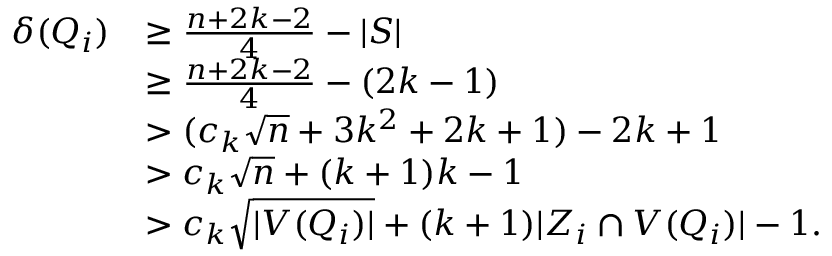<formula> <loc_0><loc_0><loc_500><loc_500>\begin{array} { r l } { \delta ( Q _ { i } ) } & { \geq \frac { n + 2 k - 2 } { 4 } - | S | } \\ & { \geq \frac { n + 2 k - 2 } { 4 } - ( 2 k - 1 ) } \\ & { > ( c _ { k } \sqrt { n } + 3 k ^ { 2 } + 2 k + 1 ) - 2 k + 1 } \\ & { > c _ { k } \sqrt { n } + ( k + 1 ) k - 1 } \\ & { > c _ { k } \sqrt { | V ( Q _ { i } ) | } + ( k + 1 ) | Z _ { i } \cap V ( Q _ { i } ) | - 1 . } \end{array}</formula> 